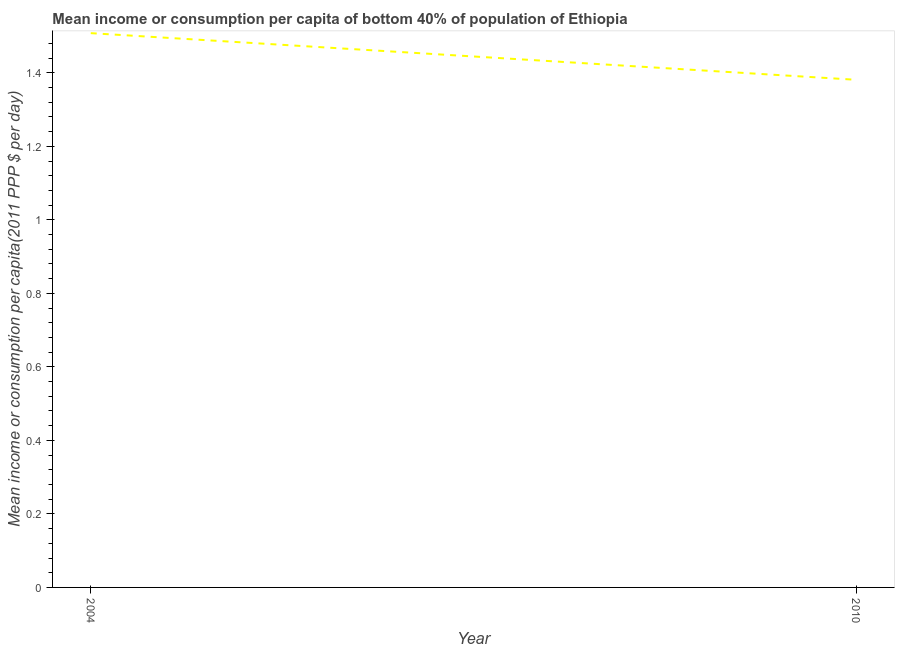What is the mean income or consumption in 2004?
Provide a succinct answer. 1.51. Across all years, what is the maximum mean income or consumption?
Provide a succinct answer. 1.51. Across all years, what is the minimum mean income or consumption?
Provide a short and direct response. 1.38. In which year was the mean income or consumption maximum?
Your answer should be very brief. 2004. What is the sum of the mean income or consumption?
Keep it short and to the point. 2.89. What is the difference between the mean income or consumption in 2004 and 2010?
Ensure brevity in your answer.  0.13. What is the average mean income or consumption per year?
Your response must be concise. 1.44. What is the median mean income or consumption?
Ensure brevity in your answer.  1.44. In how many years, is the mean income or consumption greater than 0.08 $?
Keep it short and to the point. 2. Do a majority of the years between 2010 and 2004 (inclusive) have mean income or consumption greater than 0.7200000000000001 $?
Provide a short and direct response. No. What is the ratio of the mean income or consumption in 2004 to that in 2010?
Make the answer very short. 1.09. In how many years, is the mean income or consumption greater than the average mean income or consumption taken over all years?
Offer a terse response. 1. Does the mean income or consumption monotonically increase over the years?
Your answer should be compact. No. How many lines are there?
Your answer should be compact. 1. How many years are there in the graph?
Make the answer very short. 2. What is the title of the graph?
Your response must be concise. Mean income or consumption per capita of bottom 40% of population of Ethiopia. What is the label or title of the X-axis?
Provide a succinct answer. Year. What is the label or title of the Y-axis?
Keep it short and to the point. Mean income or consumption per capita(2011 PPP $ per day). What is the Mean income or consumption per capita(2011 PPP $ per day) in 2004?
Ensure brevity in your answer.  1.51. What is the Mean income or consumption per capita(2011 PPP $ per day) in 2010?
Your answer should be compact. 1.38. What is the difference between the Mean income or consumption per capita(2011 PPP $ per day) in 2004 and 2010?
Keep it short and to the point. 0.13. What is the ratio of the Mean income or consumption per capita(2011 PPP $ per day) in 2004 to that in 2010?
Offer a terse response. 1.09. 